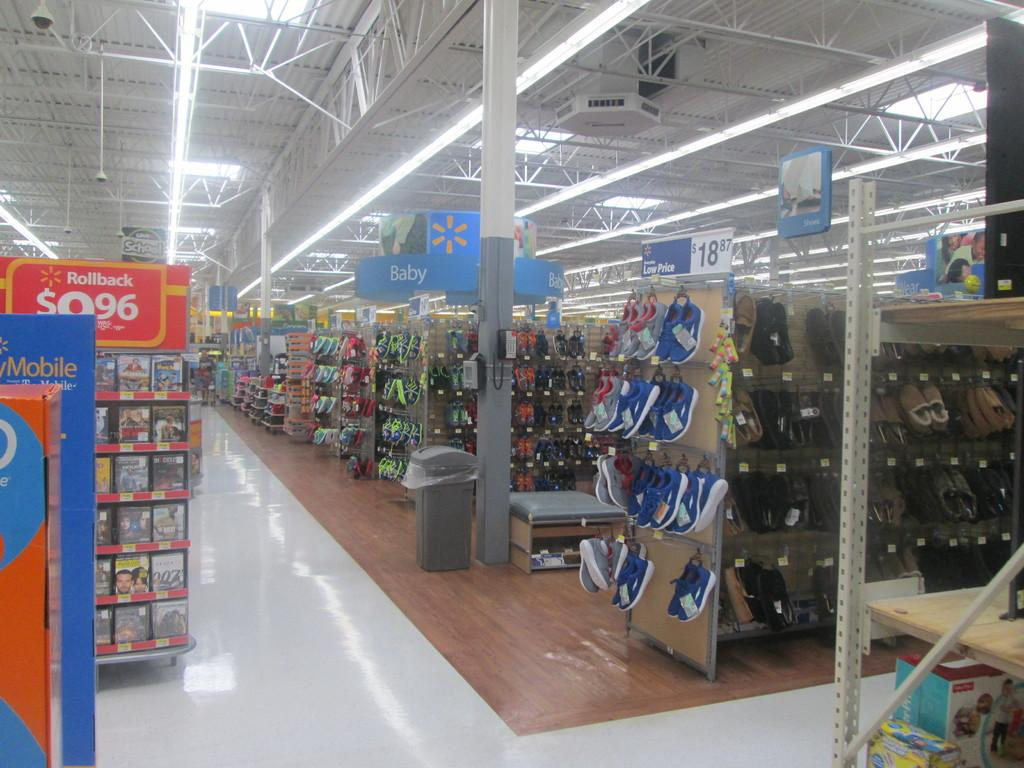<image>
Describe the image concisely. A Mobile center is on display in a Walmart Store 